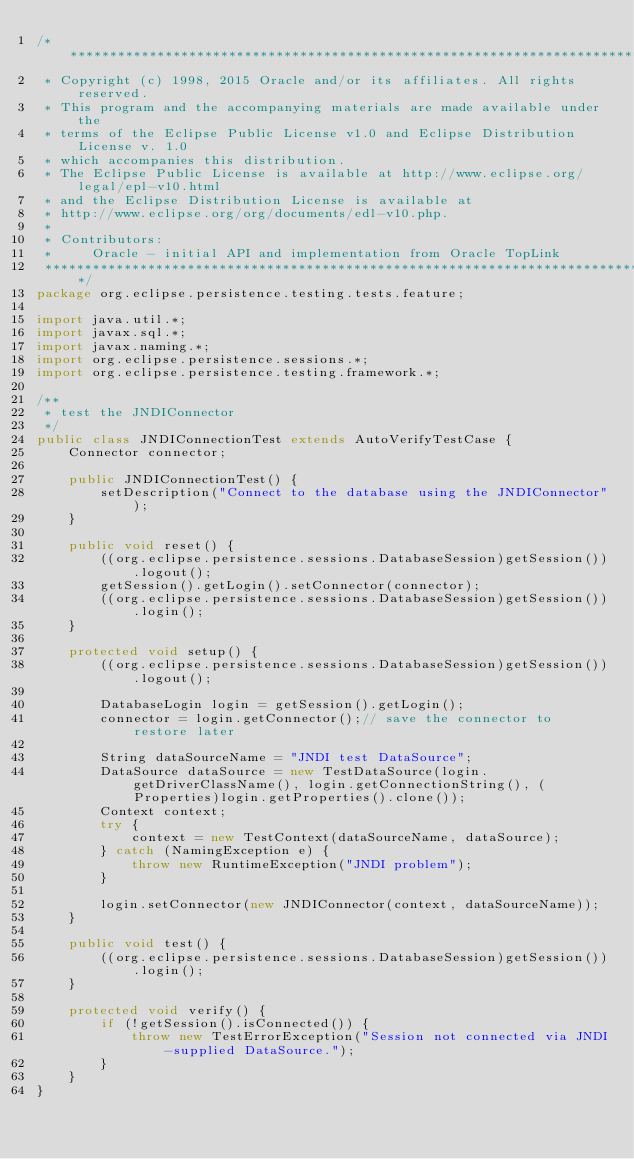Convert code to text. <code><loc_0><loc_0><loc_500><loc_500><_Java_>/*******************************************************************************
 * Copyright (c) 1998, 2015 Oracle and/or its affiliates. All rights reserved.
 * This program and the accompanying materials are made available under the
 * terms of the Eclipse Public License v1.0 and Eclipse Distribution License v. 1.0
 * which accompanies this distribution.
 * The Eclipse Public License is available at http://www.eclipse.org/legal/epl-v10.html
 * and the Eclipse Distribution License is available at
 * http://www.eclipse.org/org/documents/edl-v10.php.
 *
 * Contributors:
 *     Oracle - initial API and implementation from Oracle TopLink
 ******************************************************************************/
package org.eclipse.persistence.testing.tests.feature;

import java.util.*;
import javax.sql.*;
import javax.naming.*;
import org.eclipse.persistence.sessions.*;
import org.eclipse.persistence.testing.framework.*;

/**
 * test the JNDIConnector
 */
public class JNDIConnectionTest extends AutoVerifyTestCase {
    Connector connector;

    public JNDIConnectionTest() {
        setDescription("Connect to the database using the JNDIConnector");
    }

    public void reset() {
        ((org.eclipse.persistence.sessions.DatabaseSession)getSession()).logout();
        getSession().getLogin().setConnector(connector);
        ((org.eclipse.persistence.sessions.DatabaseSession)getSession()).login();
    }

    protected void setup() {
        ((org.eclipse.persistence.sessions.DatabaseSession)getSession()).logout();

        DatabaseLogin login = getSession().getLogin();
        connector = login.getConnector();// save the connector to restore later

        String dataSourceName = "JNDI test DataSource";
        DataSource dataSource = new TestDataSource(login.getDriverClassName(), login.getConnectionString(), (Properties)login.getProperties().clone());
        Context context;
        try {
            context = new TestContext(dataSourceName, dataSource);
        } catch (NamingException e) {
            throw new RuntimeException("JNDI problem");
        }

        login.setConnector(new JNDIConnector(context, dataSourceName));
    }

    public void test() {
        ((org.eclipse.persistence.sessions.DatabaseSession)getSession()).login();
    }

    protected void verify() {
        if (!getSession().isConnected()) {
            throw new TestErrorException("Session not connected via JNDI-supplied DataSource.");
        }
    }
}
</code> 